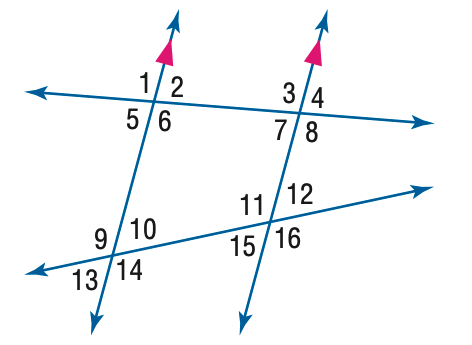Answer the mathemtical geometry problem and directly provide the correct option letter.
Question: In the figure, m \angle 3 = 110 and m \angle 12 = 55. Find the measure of \angle 6.
Choices: A: 110 B: 115 C: 120 D: 125 A 